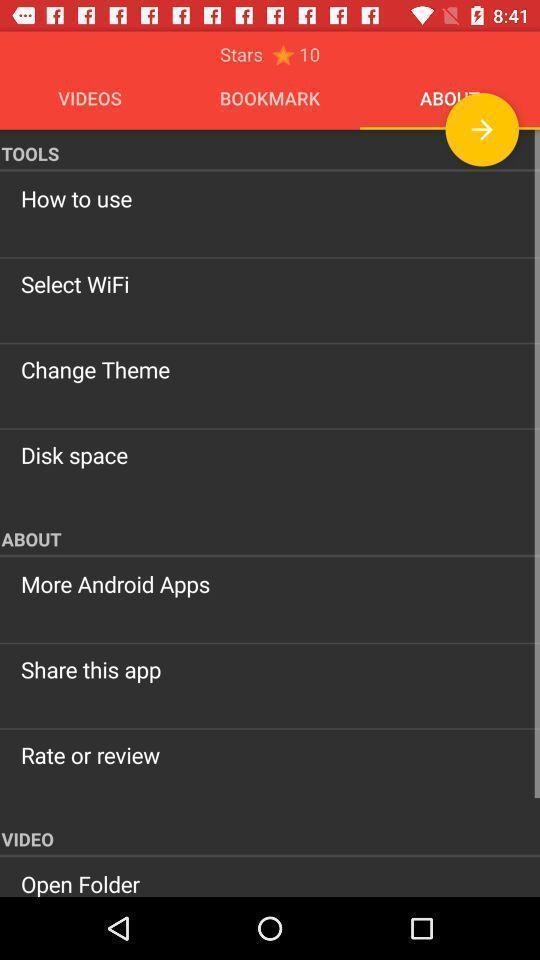Explain what's happening in this screen capture. Screen page displaying various details. 